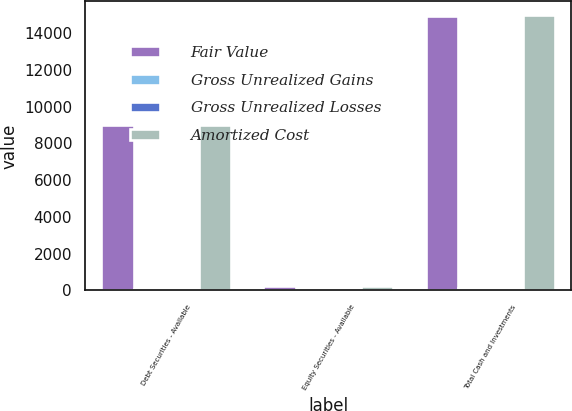<chart> <loc_0><loc_0><loc_500><loc_500><stacked_bar_chart><ecel><fcel>Debt Securities - Available<fcel>Equity Securities - Available<fcel>Total Cash and Investments<nl><fcel>Fair Value<fcel>9011<fcel>217<fcel>14930<nl><fcel>Gross Unrealized Gains<fcel>60<fcel>45<fcel>105<nl><fcel>Gross Unrealized Losses<fcel>52<fcel>1<fcel>53<nl><fcel>Amortized Cost<fcel>9019<fcel>261<fcel>14982<nl></chart> 